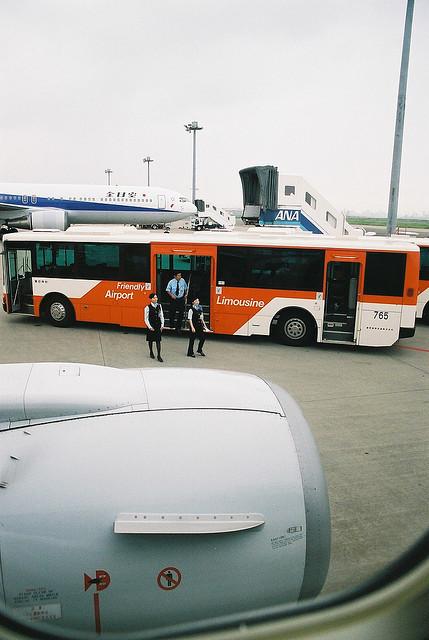What was this picture taken from inside of?
Give a very brief answer. Plane. Is the sky gray?
Give a very brief answer. Yes. How many men are in this picture?
Answer briefly. 3. 